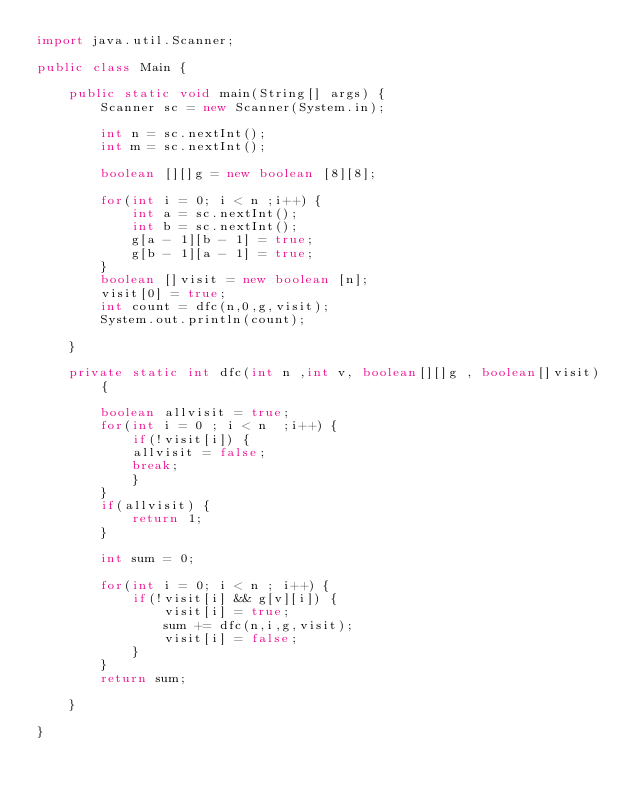Convert code to text. <code><loc_0><loc_0><loc_500><loc_500><_Java_>import java.util.Scanner;

public class Main {

	public static void main(String[] args) {
		Scanner sc = new Scanner(System.in);
		
		int n = sc.nextInt();
		int m = sc.nextInt();
		
		boolean [][]g = new boolean [8][8];
		
		for(int i = 0; i < n ;i++) {
			int a = sc.nextInt();
			int b = sc.nextInt();
			g[a - 1][b - 1] = true;
			g[b - 1][a - 1] = true;
		}
		boolean []visit = new boolean [n];
		visit[0] = true;
		int count = dfc(n,0,g,visit);
		System.out.println(count);
		
	}
	
	private static int dfc(int n ,int v, boolean[][]g , boolean[]visit) {
		
		boolean allvisit = true;
		for(int i = 0 ; i < n  ;i++) {
			if(!visit[i]) {
			allvisit = false;
			break;
			}
		}
		if(allvisit) {
			return 1;
		}
		
		int sum = 0;
		
		for(int i = 0; i < n ; i++) {
			if(!visit[i] && g[v][i]) {
				visit[i] = true;
				sum += dfc(n,i,g,visit);
				visit[i] = false;
			}
		}
		return sum;
		
	}

}
</code> 